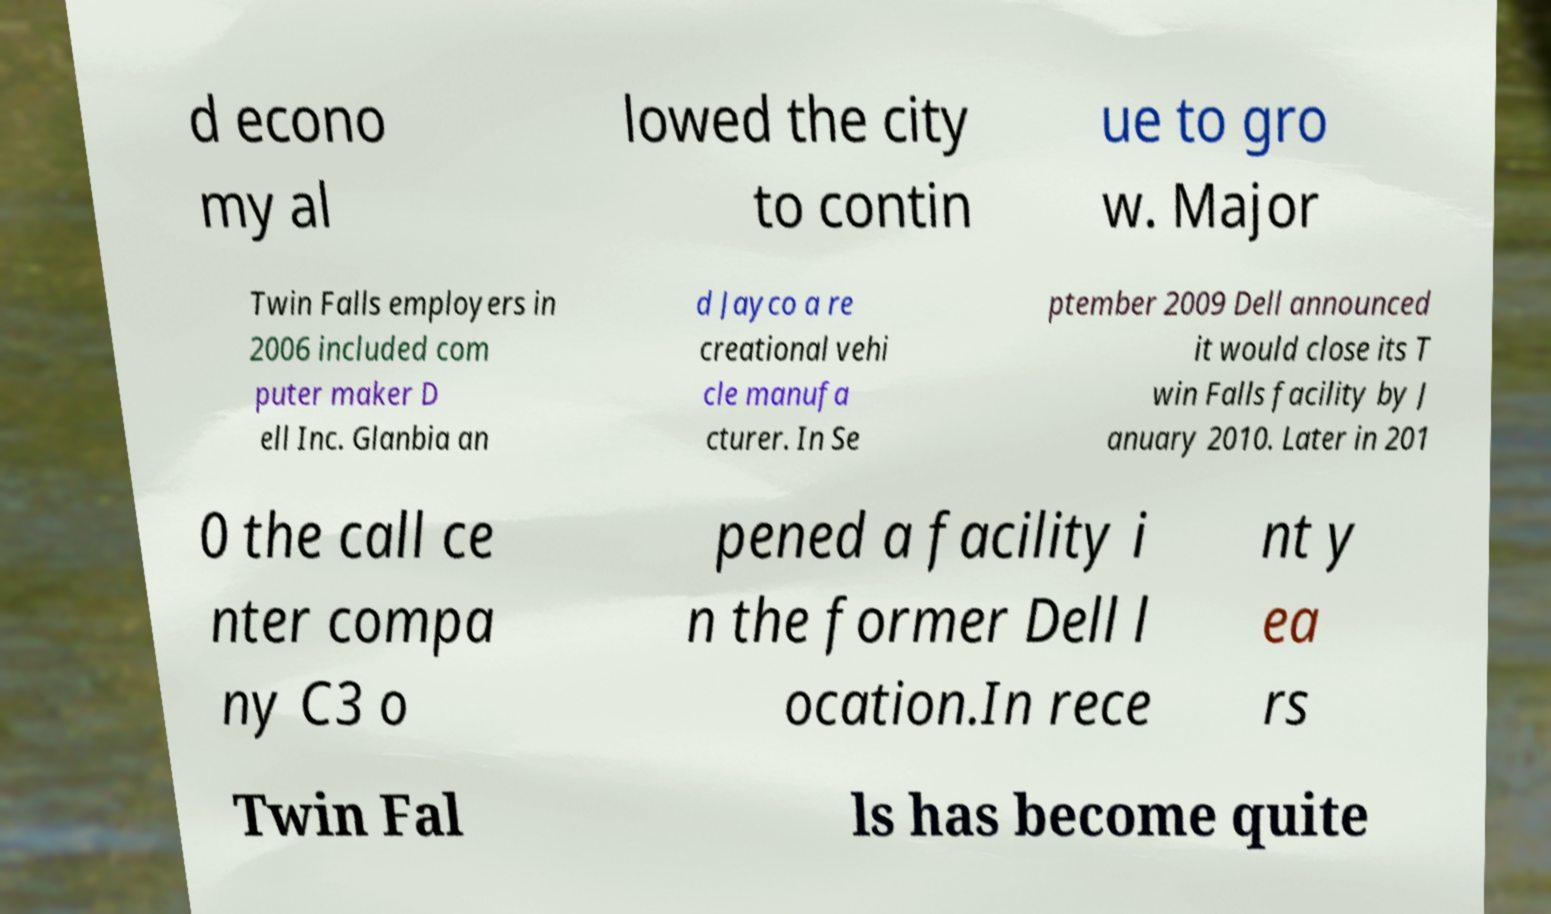Can you read and provide the text displayed in the image?This photo seems to have some interesting text. Can you extract and type it out for me? d econo my al lowed the city to contin ue to gro w. Major Twin Falls employers in 2006 included com puter maker D ell Inc. Glanbia an d Jayco a re creational vehi cle manufa cturer. In Se ptember 2009 Dell announced it would close its T win Falls facility by J anuary 2010. Later in 201 0 the call ce nter compa ny C3 o pened a facility i n the former Dell l ocation.In rece nt y ea rs Twin Fal ls has become quite 